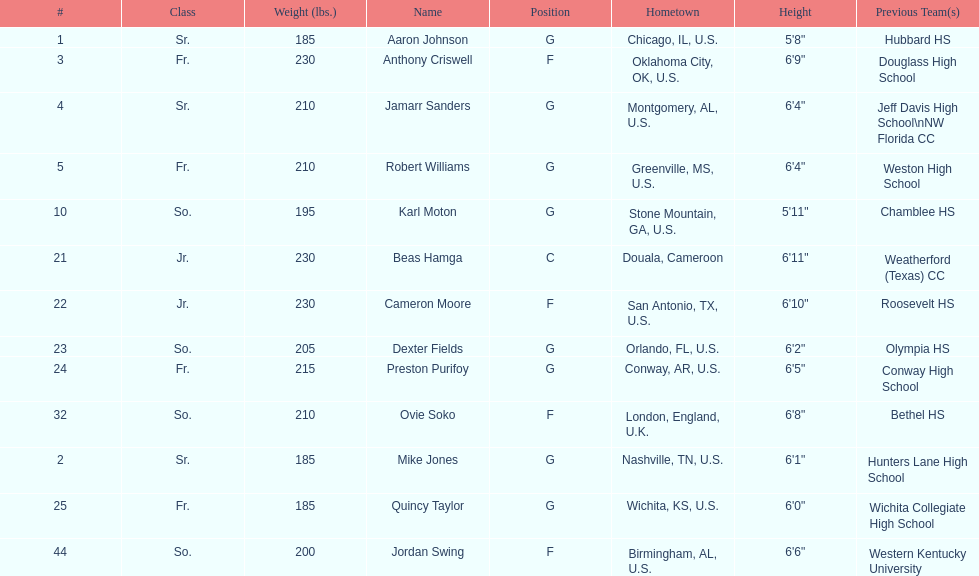Tell me the number of juniors on the team. 2. 